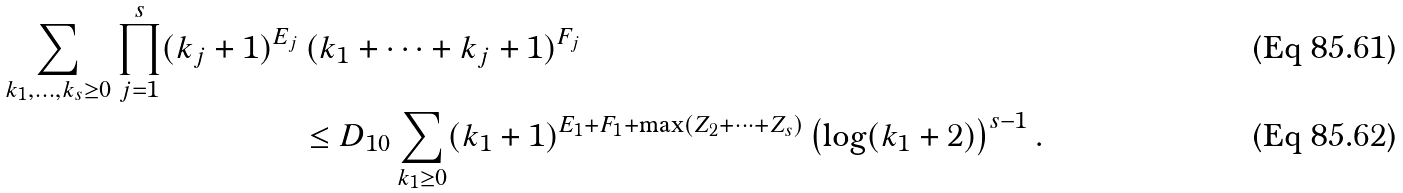<formula> <loc_0><loc_0><loc_500><loc_500>\sum _ { k _ { 1 } , \dots , k _ { s } \geq 0 } \prod _ { j = 1 } ^ { s } ( k _ { j } + 1 ) ^ { E _ { j } } & \, ( k _ { 1 } + \dots + k _ { j } + 1 ) ^ { F _ { j } } \\ & \leq D _ { 1 0 } \sum _ { k _ { 1 } \geq 0 } ( k _ { 1 } + 1 ) ^ { E _ { 1 } + F _ { 1 } + \max ( Z _ { 2 } + \dots + Z _ { s } ) } \left ( \log ( k _ { 1 } + 2 ) \right ) ^ { s - 1 } .</formula> 